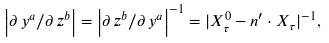<formula> <loc_0><loc_0><loc_500><loc_500>\left | \partial \, y ^ { a } / \partial \, z ^ { b } \right | = \left | \partial \, z ^ { b } / \partial \, y ^ { a } \right | ^ { - 1 } = | X _ { \tau } ^ { 0 } - n ^ { \prime } \cdot X _ { \tau } | ^ { - 1 } ,</formula> 